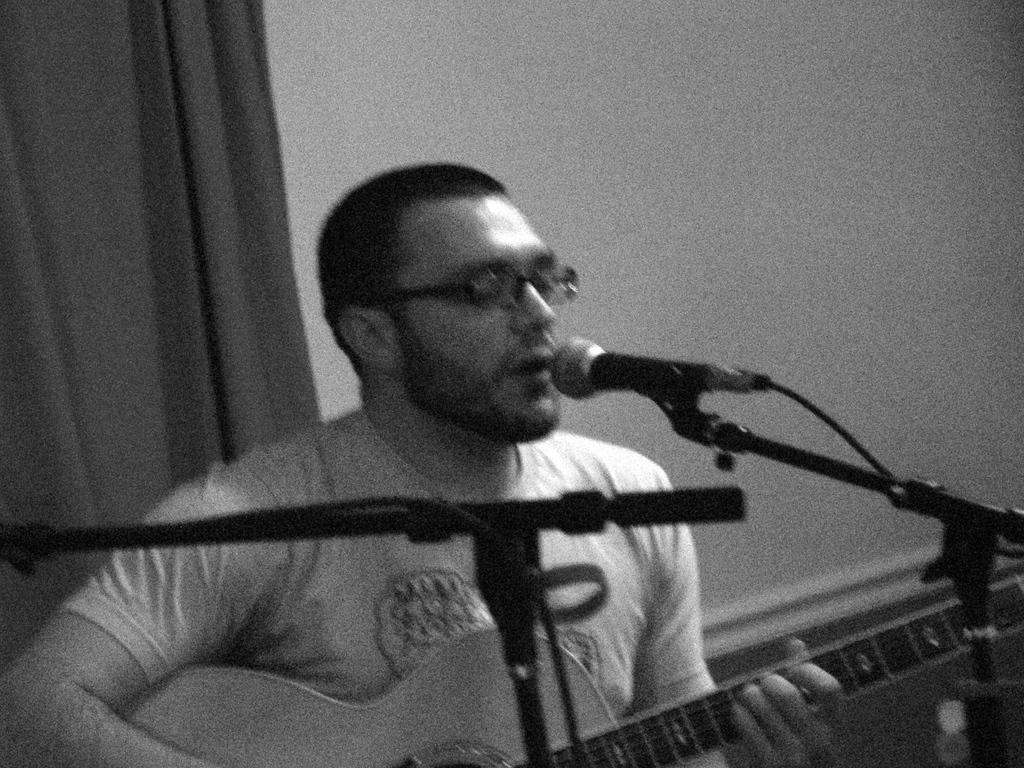What is the person in the image doing? The person is singing a song. What is the person holding while singing? The person is holding a microphone. What musical instrument is the person playing? The person is playing a guitar. What type of chain is being used to sort the time in the image? There is no chain or time-sorting activity present in the image; it features a person singing and playing a guitar. 